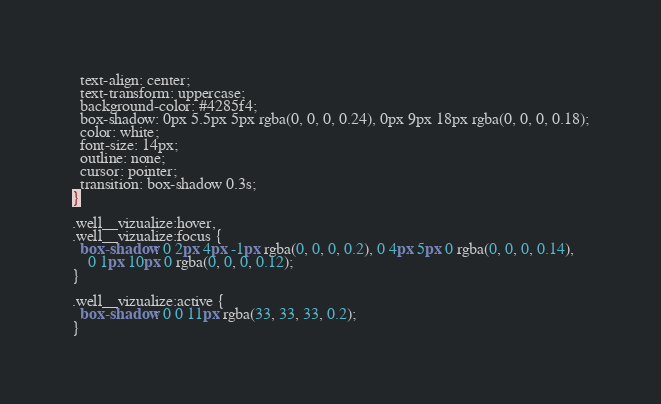Convert code to text. <code><loc_0><loc_0><loc_500><loc_500><_CSS_>  text-align: center;
  text-transform: uppercase;
  background-color: #4285f4;
  box-shadow: 0px 5.5px 5px rgba(0, 0, 0, 0.24), 0px 9px 18px rgba(0, 0, 0, 0.18);
  color: white;
  font-size: 14px;
  outline: none;
  cursor: pointer;
  transition: box-shadow 0.3s;
}

.well__vizualize:hover,
.well__vizualize:focus {
  box-shadow: 0 2px 4px -1px rgba(0, 0, 0, 0.2), 0 4px 5px 0 rgba(0, 0, 0, 0.14),
    0 1px 10px 0 rgba(0, 0, 0, 0.12);
}

.well__vizualize:active {
  box-shadow: 0 0 11px rgba(33, 33, 33, 0.2);
}
</code> 